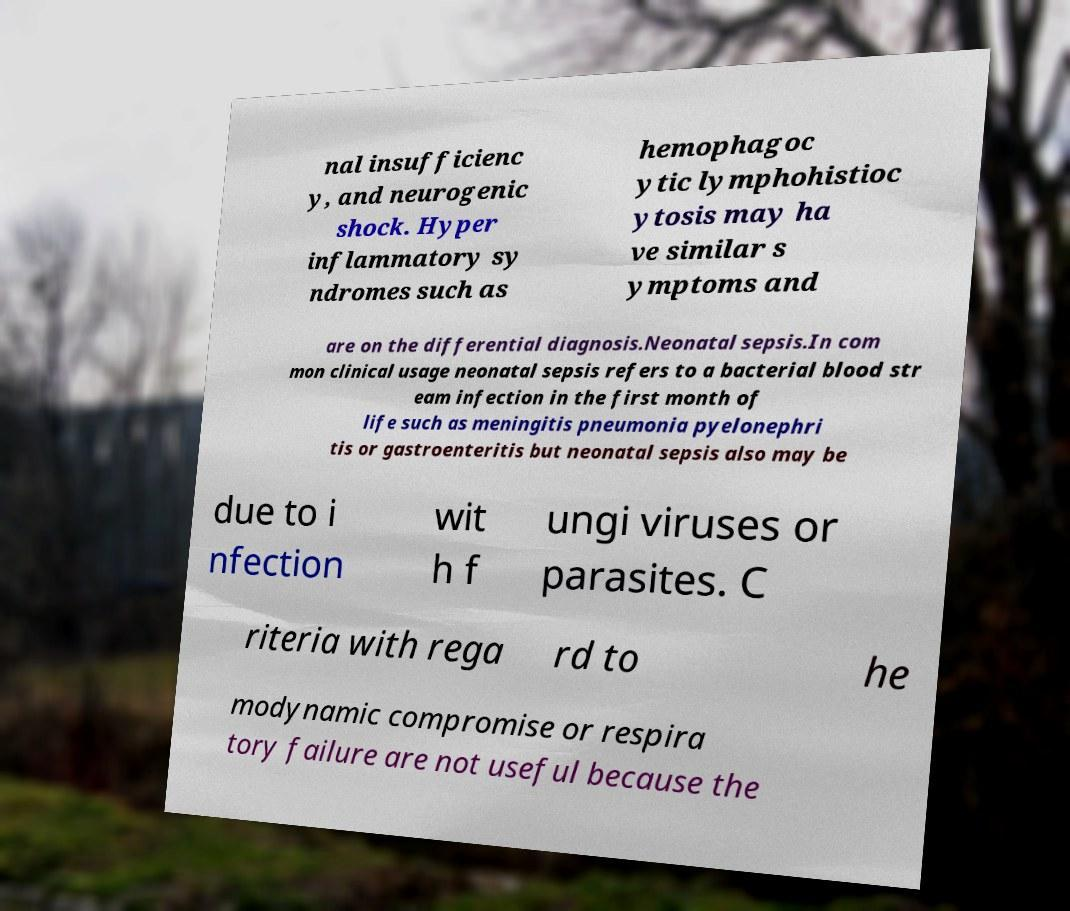Can you accurately transcribe the text from the provided image for me? nal insufficienc y, and neurogenic shock. Hyper inflammatory sy ndromes such as hemophagoc ytic lymphohistioc ytosis may ha ve similar s ymptoms and are on the differential diagnosis.Neonatal sepsis.In com mon clinical usage neonatal sepsis refers to a bacterial blood str eam infection in the first month of life such as meningitis pneumonia pyelonephri tis or gastroenteritis but neonatal sepsis also may be due to i nfection wit h f ungi viruses or parasites. C riteria with rega rd to he modynamic compromise or respira tory failure are not useful because the 